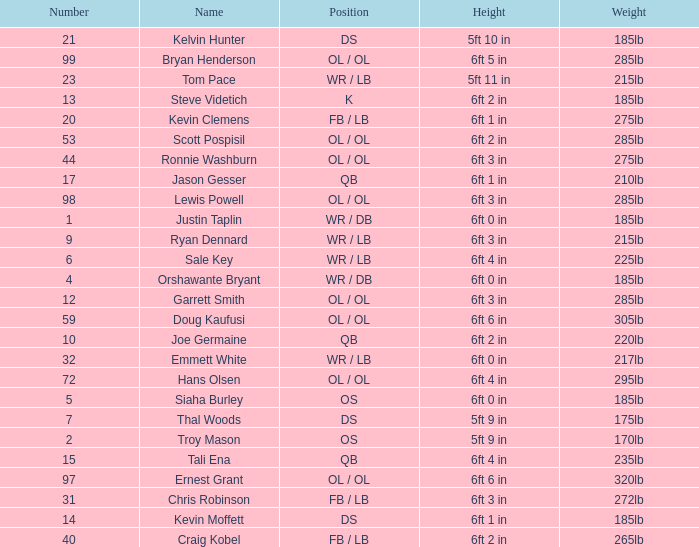What is the number for the player that has a k position? 13.0. 